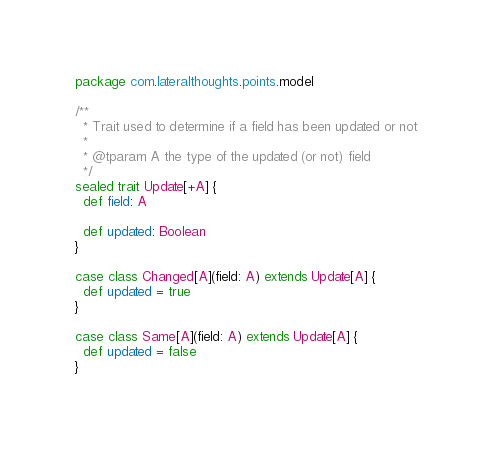Convert code to text. <code><loc_0><loc_0><loc_500><loc_500><_Scala_>package com.lateralthoughts.points.model

/**
  * Trait used to determine if a field has been updated or not
  *
  * @tparam A the type of the updated (or not) field
  */
sealed trait Update[+A] {
  def field: A

  def updated: Boolean
}

case class Changed[A](field: A) extends Update[A] {
  def updated = true
}

case class Same[A](field: A) extends Update[A] {
  def updated = false
}
</code> 